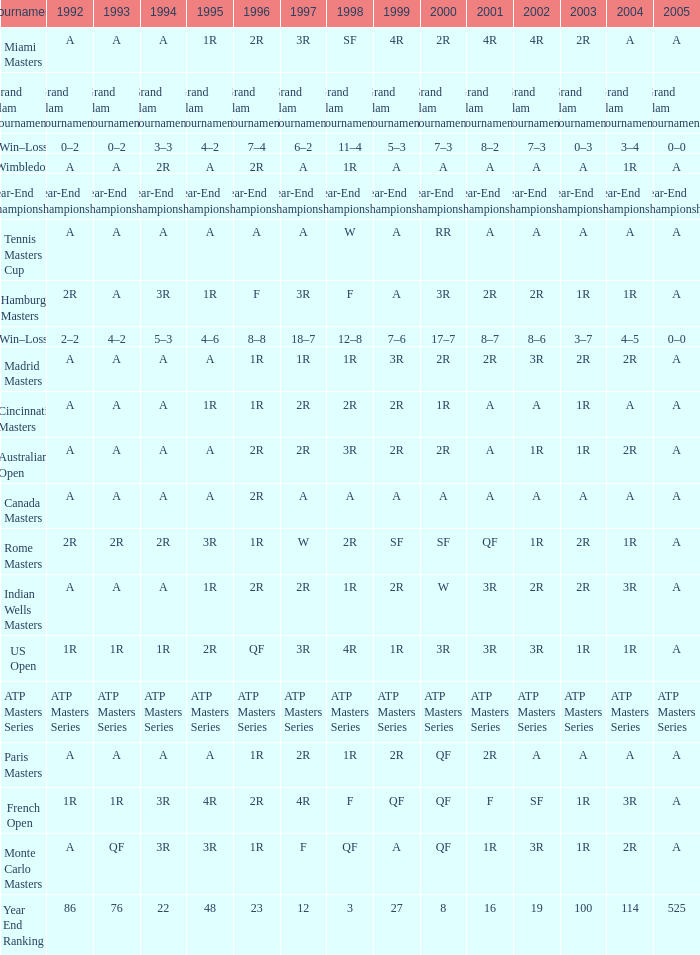What is Tournament, when 2000 is "A"? Wimbledon, Canada Masters. 